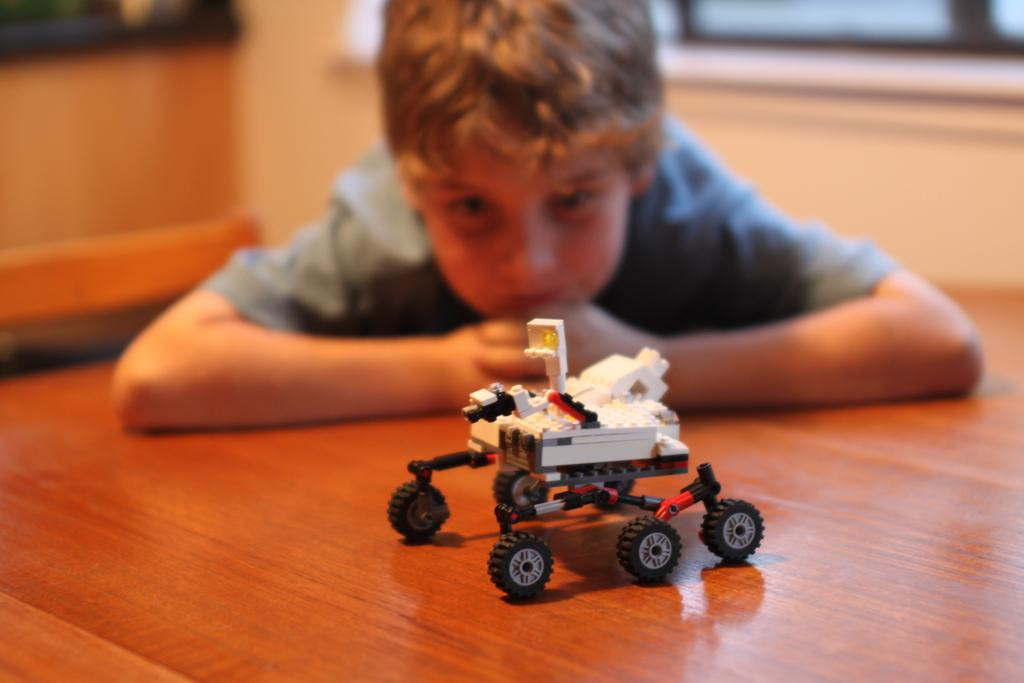What is on the floor in the image? There is a toy on the floor. Can you describe the boy in the background? The boy is visible in the background, wearing a t-shirt and laying on the floor. What is the boy doing in the image? The boy is looking at the toy. How is the background of the image depicted? The background is blurred. What type of game is the boy controlling with his hand in the image? There is no game or hand visible in the image; the boy is simply looking at the toy on the floor. 